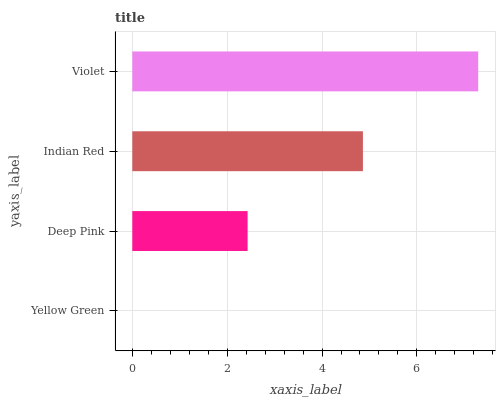Is Yellow Green the minimum?
Answer yes or no. Yes. Is Violet the maximum?
Answer yes or no. Yes. Is Deep Pink the minimum?
Answer yes or no. No. Is Deep Pink the maximum?
Answer yes or no. No. Is Deep Pink greater than Yellow Green?
Answer yes or no. Yes. Is Yellow Green less than Deep Pink?
Answer yes or no. Yes. Is Yellow Green greater than Deep Pink?
Answer yes or no. No. Is Deep Pink less than Yellow Green?
Answer yes or no. No. Is Indian Red the high median?
Answer yes or no. Yes. Is Deep Pink the low median?
Answer yes or no. Yes. Is Yellow Green the high median?
Answer yes or no. No. Is Violet the low median?
Answer yes or no. No. 